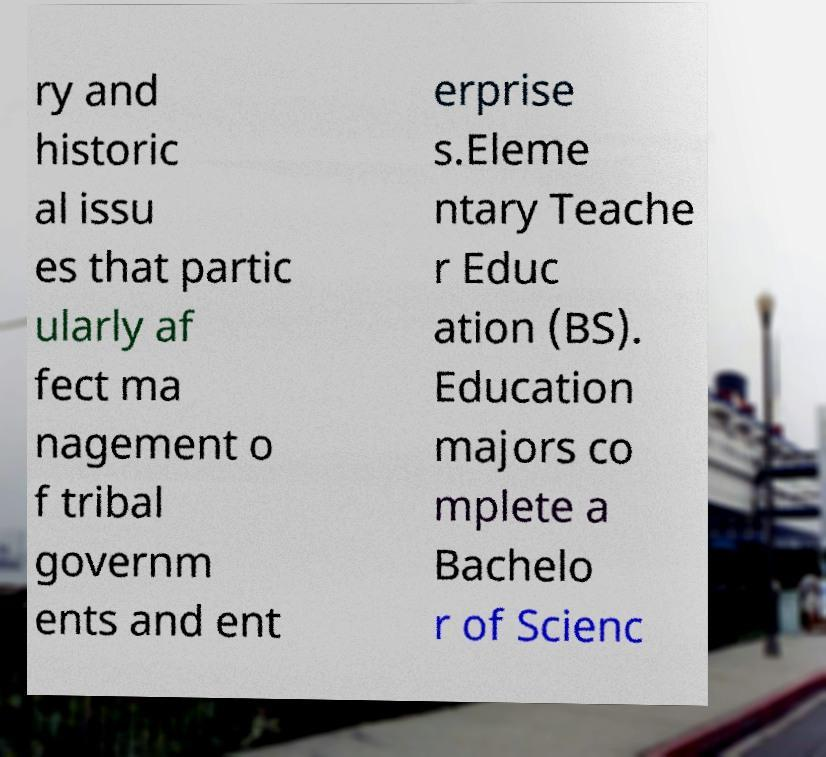Can you read and provide the text displayed in the image?This photo seems to have some interesting text. Can you extract and type it out for me? ry and historic al issu es that partic ularly af fect ma nagement o f tribal governm ents and ent erprise s.Eleme ntary Teache r Educ ation (BS). Education majors co mplete a Bachelo r of Scienc 